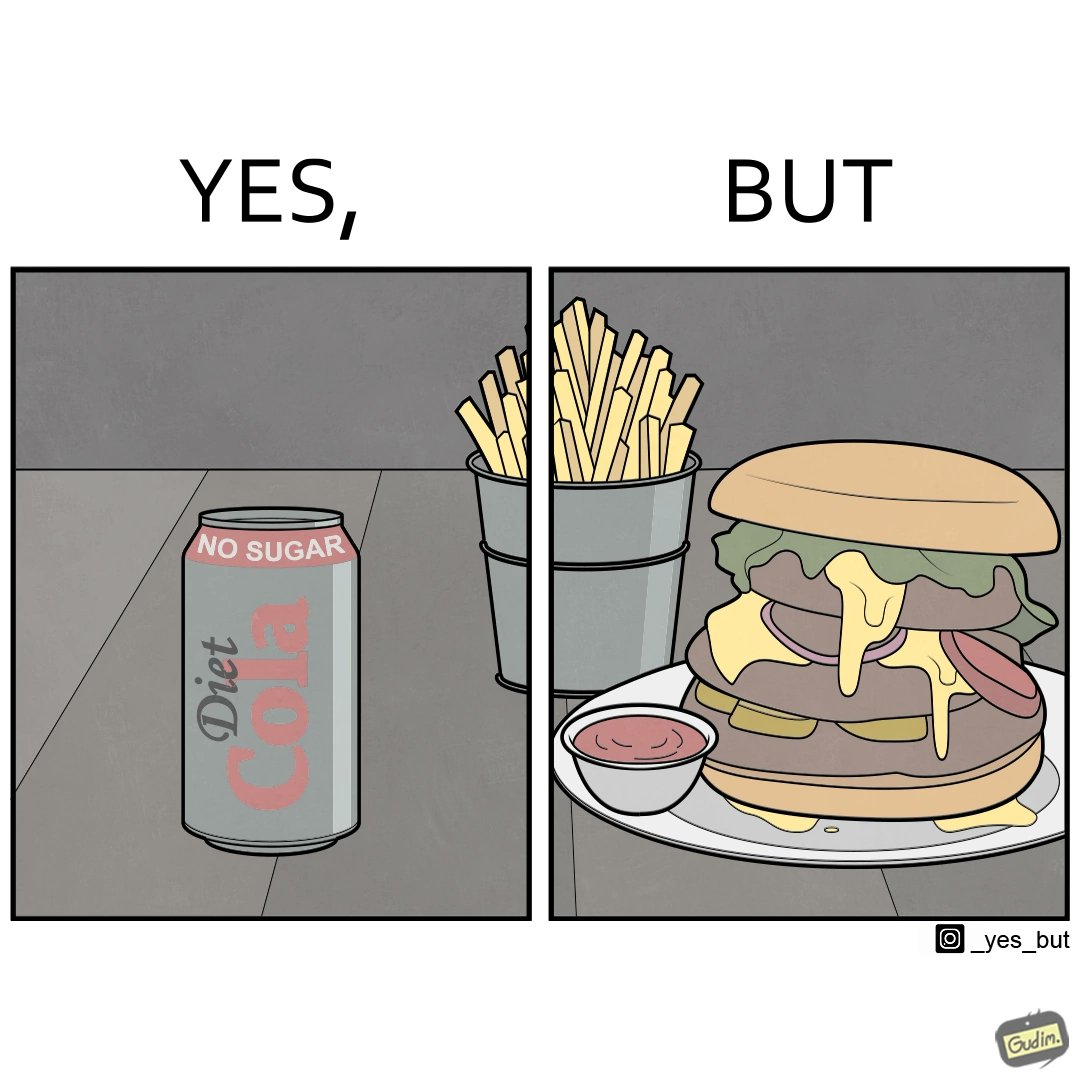Explain why this image is satirical. The image is ironic, because on one hand the person is consuming diet cola suggesting low on sugar as per label meaning the person is health-conscious but on the other hand the same one is having huge size burger with french fries which suggests the person to be health-ignorant 